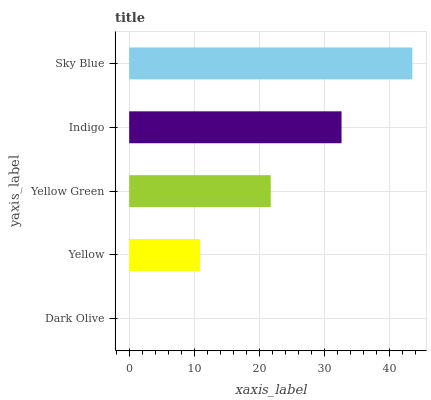Is Dark Olive the minimum?
Answer yes or no. Yes. Is Sky Blue the maximum?
Answer yes or no. Yes. Is Yellow the minimum?
Answer yes or no. No. Is Yellow the maximum?
Answer yes or no. No. Is Yellow greater than Dark Olive?
Answer yes or no. Yes. Is Dark Olive less than Yellow?
Answer yes or no. Yes. Is Dark Olive greater than Yellow?
Answer yes or no. No. Is Yellow less than Dark Olive?
Answer yes or no. No. Is Yellow Green the high median?
Answer yes or no. Yes. Is Yellow Green the low median?
Answer yes or no. Yes. Is Yellow the high median?
Answer yes or no. No. Is Indigo the low median?
Answer yes or no. No. 